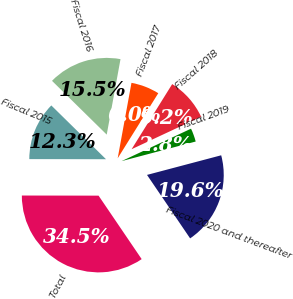<chart> <loc_0><loc_0><loc_500><loc_500><pie_chart><fcel>Fiscal 2015<fcel>Fiscal 2016<fcel>Fiscal 2017<fcel>Fiscal 2018<fcel>Fiscal 2019<fcel>Fiscal 2020 and thereafter<fcel>Total<nl><fcel>12.34%<fcel>15.51%<fcel>6.0%<fcel>9.17%<fcel>2.84%<fcel>19.62%<fcel>34.52%<nl></chart> 